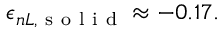<formula> <loc_0><loc_0><loc_500><loc_500>\epsilon _ { n L , s o l i d } \approx - 0 . 1 7 .</formula> 